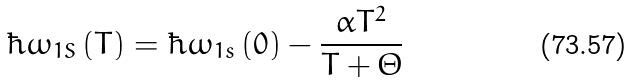Convert formula to latex. <formula><loc_0><loc_0><loc_500><loc_500>\hbar { \omega } _ { 1 S } \left ( T \right ) = \hbar { \omega } _ { 1 s } \left ( { 0 } \right ) - \frac { \alpha T ^ { 2 } } { T + \Theta }</formula> 